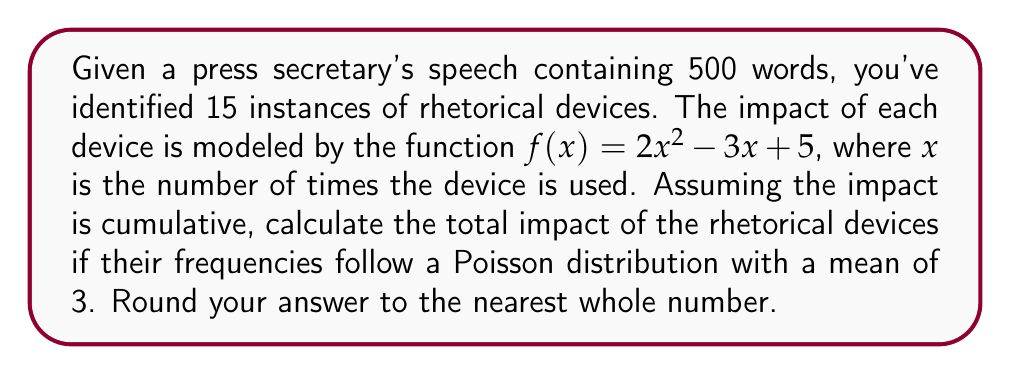Solve this math problem. 1) First, we need to understand the Poisson distribution. The probability of $k$ occurrences in a Poisson distribution with mean $\lambda$ is given by:

   $$P(X = k) = \frac{e^{-\lambda}\lambda^k}{k!}$$

2) We're given that $\lambda = 3$ and we need to consider up to 15 instances (as that's the maximum identified in the speech).

3) For each possible number of occurrences $k$ from 0 to 15, we need to:
   a) Calculate the probability $P(X = k)$
   b) Calculate the impact $f(k) = 2k^2 - 3k + 5$
   c) Multiply these together

4) The total impact will be the sum of these products. Mathematically:

   $$\text{Total Impact} = \sum_{k=0}^{15} P(X = k) \cdot f(k)$$

5) Let's calculate this step by step:

   For $k = 0$: $P(X = 0) = 0.0498$ and $f(0) = 5$
               $0.0498 \cdot 5 = 0.2490$
   
   For $k = 1$: $P(X = 1) = 0.1494$ and $f(1) = 4$
               $0.1494 \cdot 4 = 0.5976$
   
   For $k = 2$: $P(X = 2) = 0.2240$ and $f(2) = 7$
               $0.2240 \cdot 7 = 1.5680$
   
   ...

   For $k = 15$: $P(X = 15) \approx 0$ and $f(15) = 440$
                $0 \cdot 440 \approx 0$

6) Summing all these products gives us approximately 22.8741.

7) Rounding to the nearest whole number, we get 23.
Answer: 23 